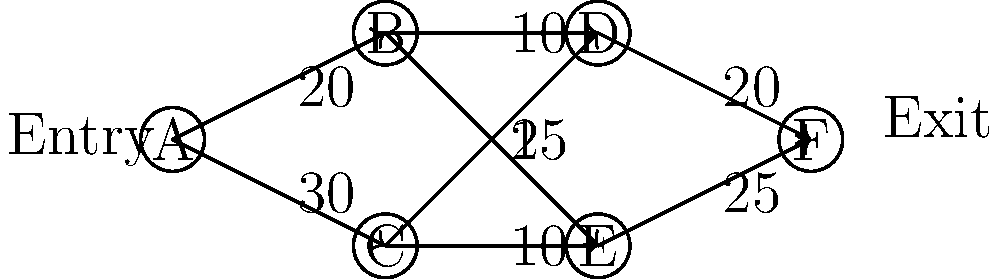In a high-rise building, you're analyzing the maximum flow of workers through emergency exit routes. The graph represents different sections of the building (nodes) and the maximum number of people that can pass through each route (edge weights) per minute. What is the maximum number of workers that can safely exit the building per minute? To solve this maximum flow problem, we'll use the Ford-Fulkerson algorithm:

1. Identify the source (A) and sink (F) nodes.

2. Find augmenting paths from A to F:
   Path 1: A-B-D-F (min capacity: 10)
   Path 2: A-C-D-F (min capacity: 20)
   Path 3: A-B-E-F (min capacity: 15)
   Path 4: A-C-E-F (min capacity: 10)

3. Calculate the total flow:
   Path 1: 10
   Path 2: 20
   Path 3: 10 (B-E capacity reduced to 5)
   Path 4: 5 (A-C capacity reduced to 5)

4. Sum up the flows:
   Total maximum flow = 10 + 20 + 10 + 5 = 45

Therefore, the maximum number of workers that can safely exit the building per minute is 45.
Answer: 45 workers per minute 